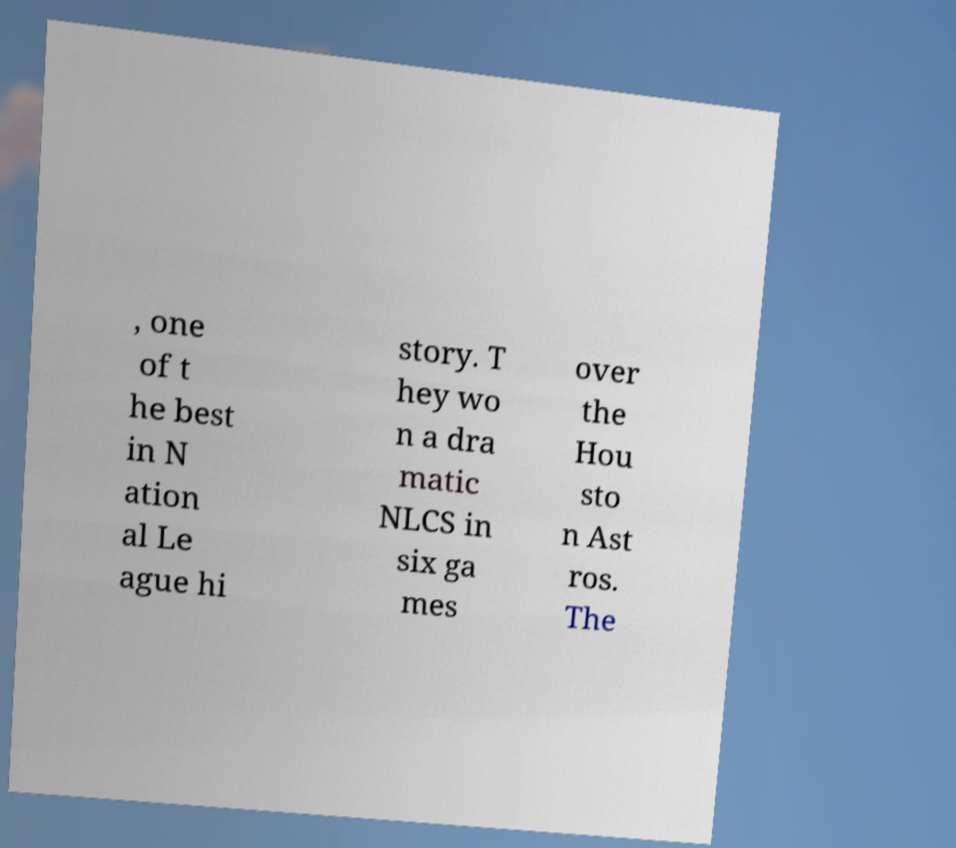Could you assist in decoding the text presented in this image and type it out clearly? , one of t he best in N ation al Le ague hi story. T hey wo n a dra matic NLCS in six ga mes over the Hou sto n Ast ros. The 